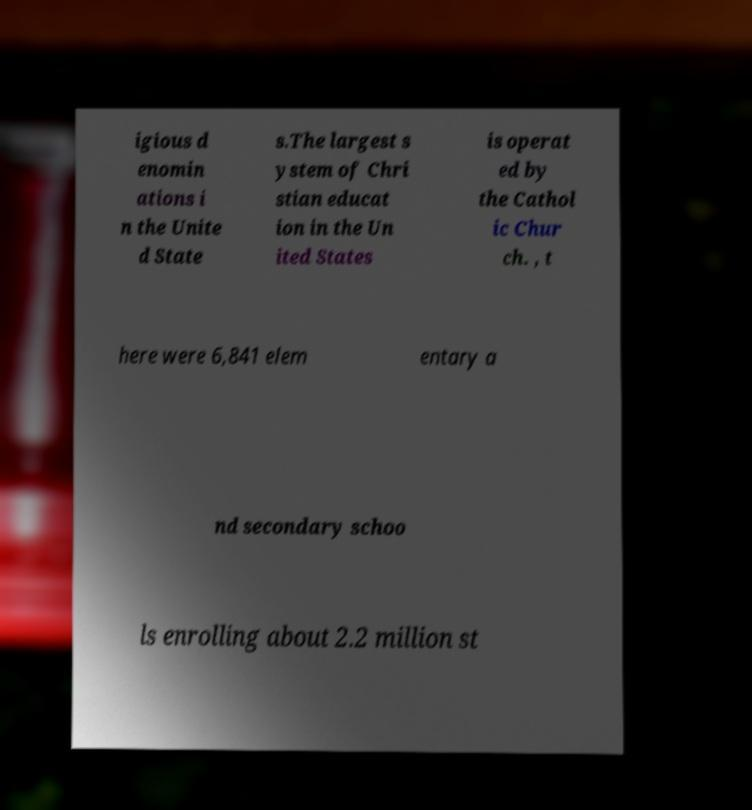Can you accurately transcribe the text from the provided image for me? igious d enomin ations i n the Unite d State s.The largest s ystem of Chri stian educat ion in the Un ited States is operat ed by the Cathol ic Chur ch. , t here were 6,841 elem entary a nd secondary schoo ls enrolling about 2.2 million st 